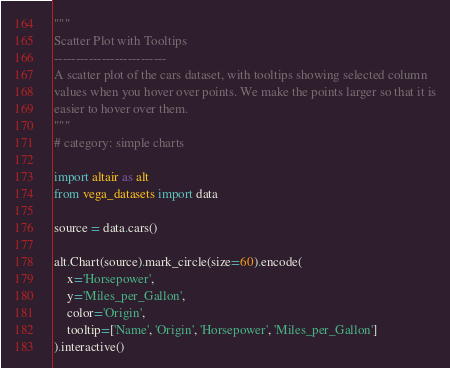Convert code to text. <code><loc_0><loc_0><loc_500><loc_500><_Python_>"""
Scatter Plot with Tooltips
--------------------------
A scatter plot of the cars dataset, with tooltips showing selected column
values when you hover over points. We make the points larger so that it is
easier to hover over them.
"""
# category: simple charts

import altair as alt
from vega_datasets import data

source = data.cars()

alt.Chart(source).mark_circle(size=60).encode(
    x='Horsepower',
    y='Miles_per_Gallon',
    color='Origin',
    tooltip=['Name', 'Origin', 'Horsepower', 'Miles_per_Gallon']
).interactive()
</code> 